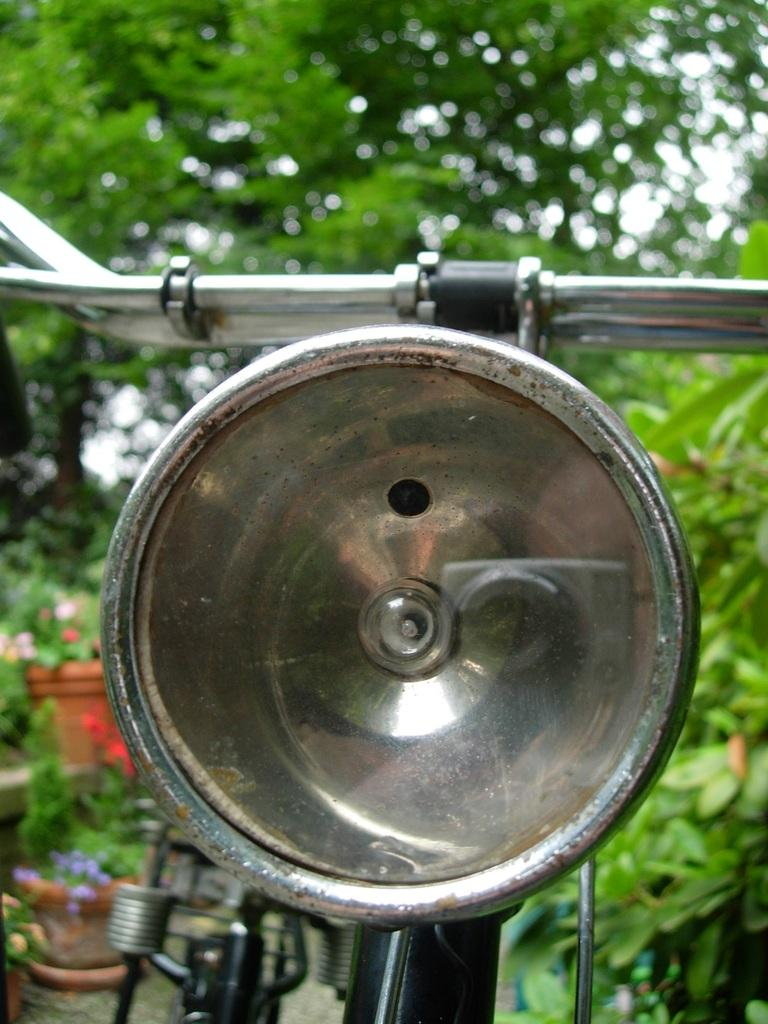What is the main mode of transportation in the image? There is a cycle in the image. What other elements can be seen in the image besides the cycle? There are plants in the image. What color dominates the background of the image? The background of the image is green. What type of alley can be seen in the image? There is no alley present in the image. Is the image depicting a winter scene? The image does not provide any information about the season, so it cannot be determined if it is a winter scene. 